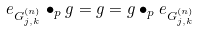<formula> <loc_0><loc_0><loc_500><loc_500>e _ { G _ { j , k } ^ { ( n ) } } \bullet _ { p } g = g = g \bullet _ { p } e _ { G _ { j , k } ^ { ( n ) } }</formula> 